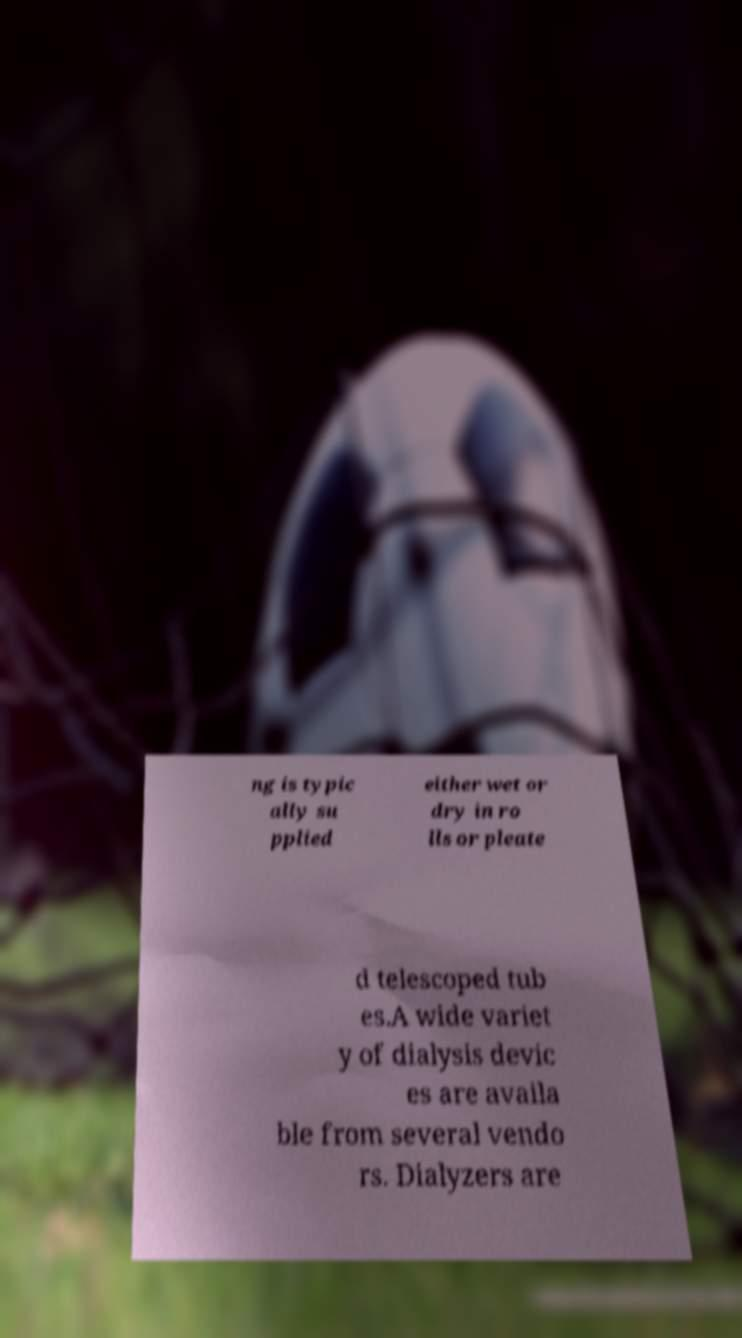Can you accurately transcribe the text from the provided image for me? ng is typic ally su pplied either wet or dry in ro lls or pleate d telescoped tub es.A wide variet y of dialysis devic es are availa ble from several vendo rs. Dialyzers are 